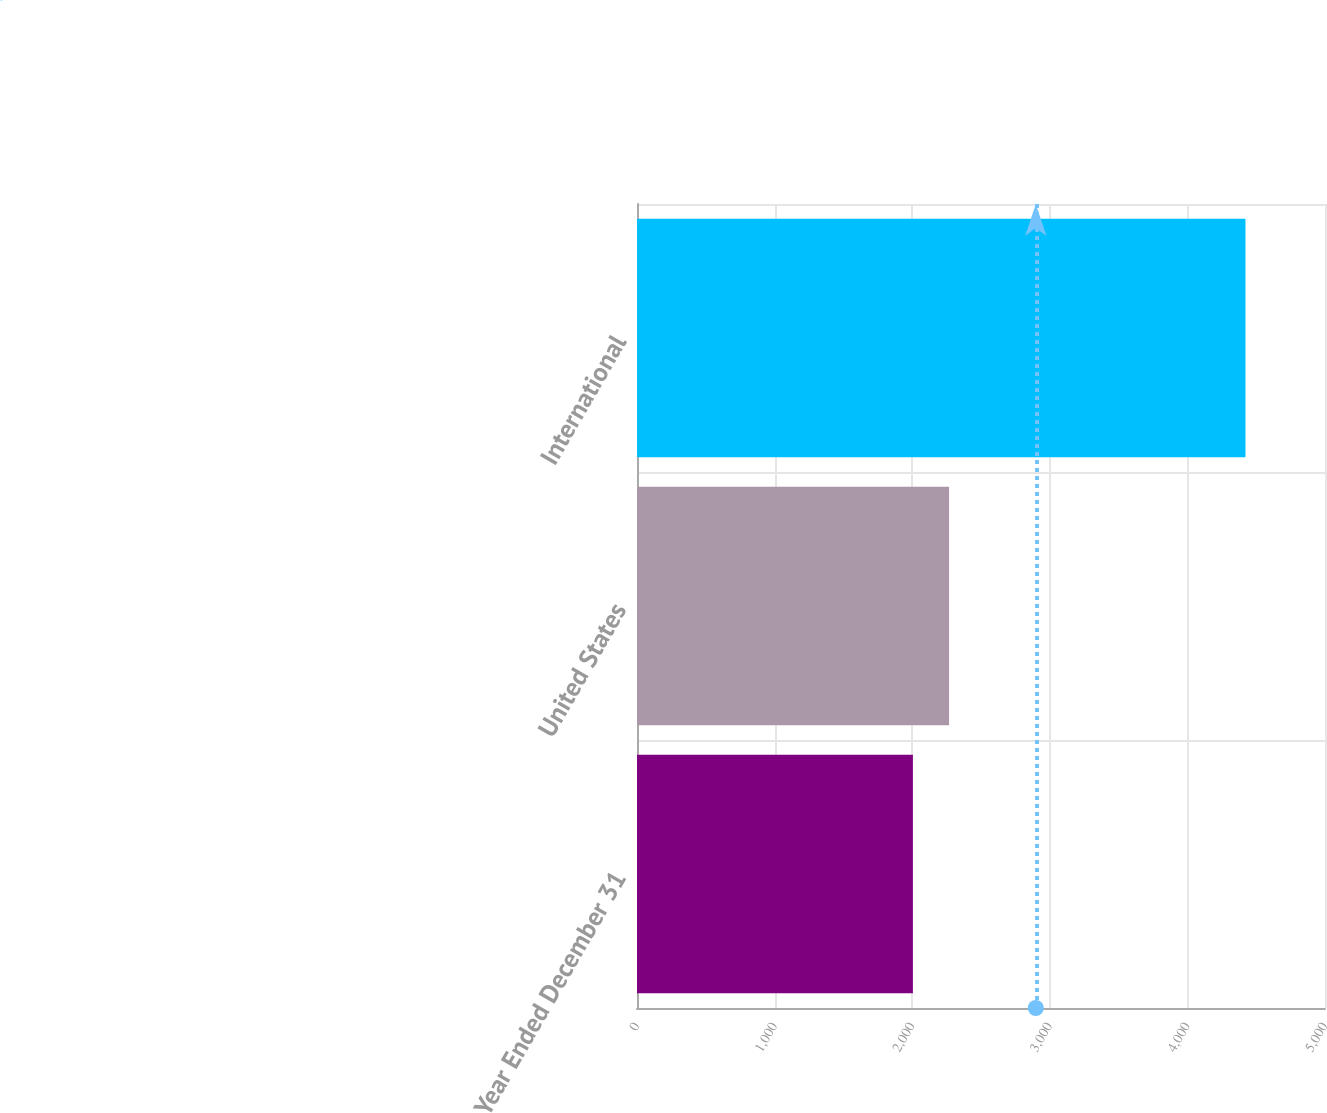Convert chart to OTSL. <chart><loc_0><loc_0><loc_500><loc_500><bar_chart><fcel>Year Ended December 31<fcel>United States<fcel>International<nl><fcel>2005<fcel>2268<fcel>4422<nl></chart> 